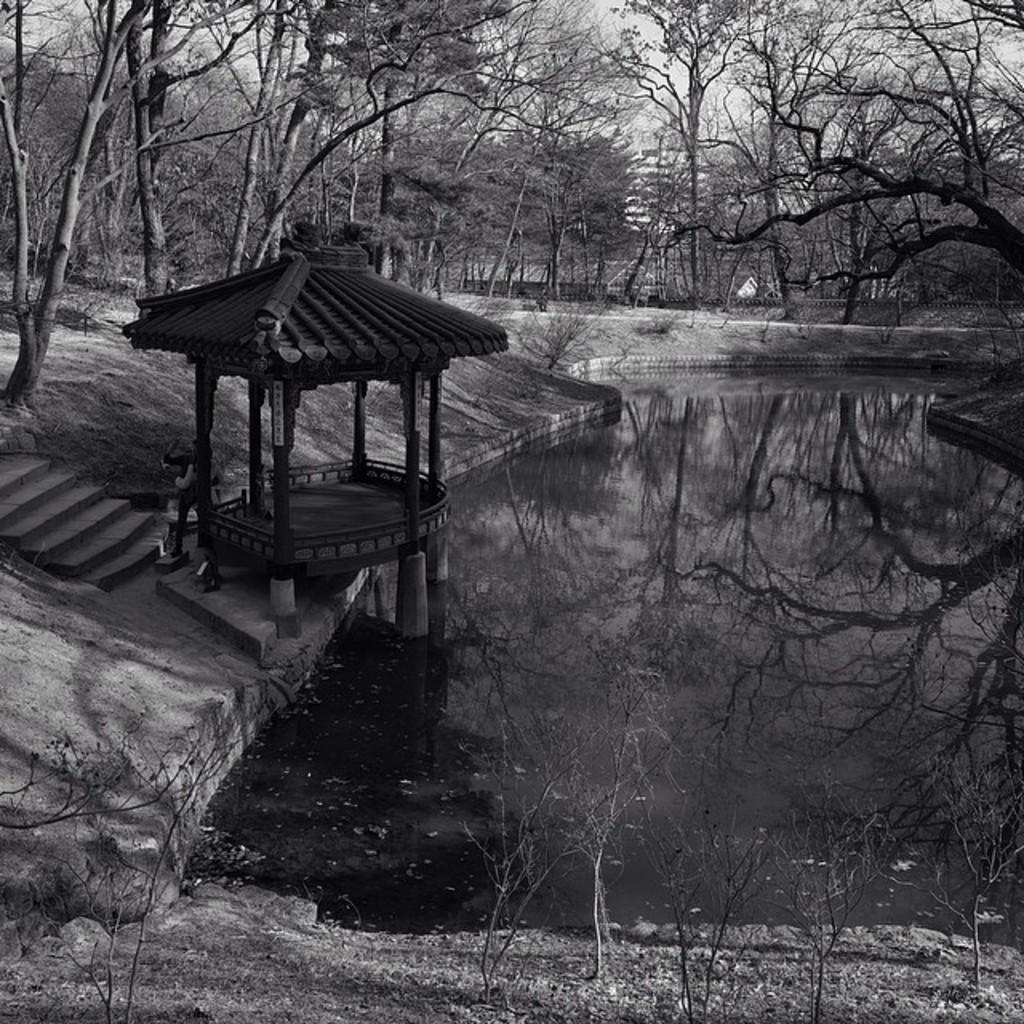Please provide a concise description of this image. In this picture we can see watershed, steps, trees and we can see sky in the background. 